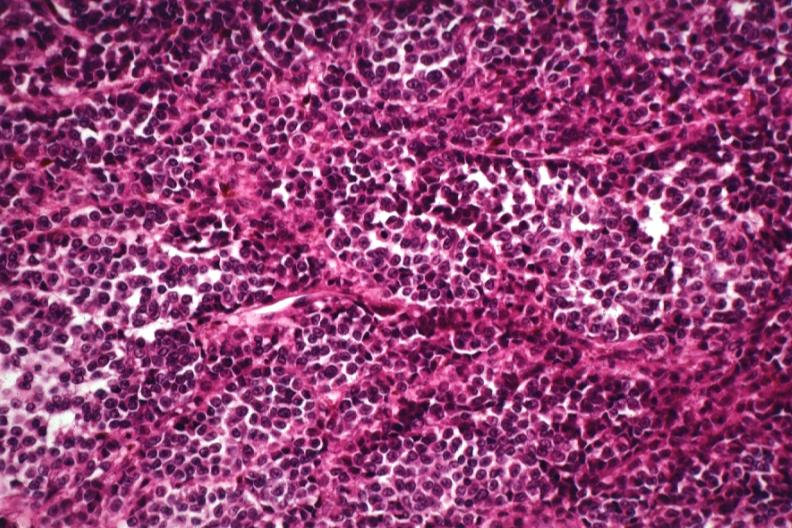what does this image show?
Answer the question using a single word or phrase. Cells deep in skin lesion with no pigment 